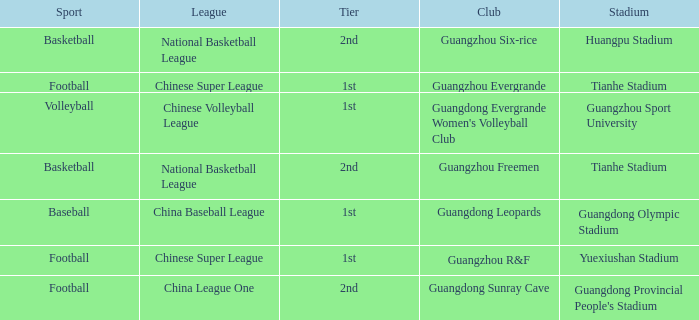Which tier is for football at Tianhe Stadium? 1st. 